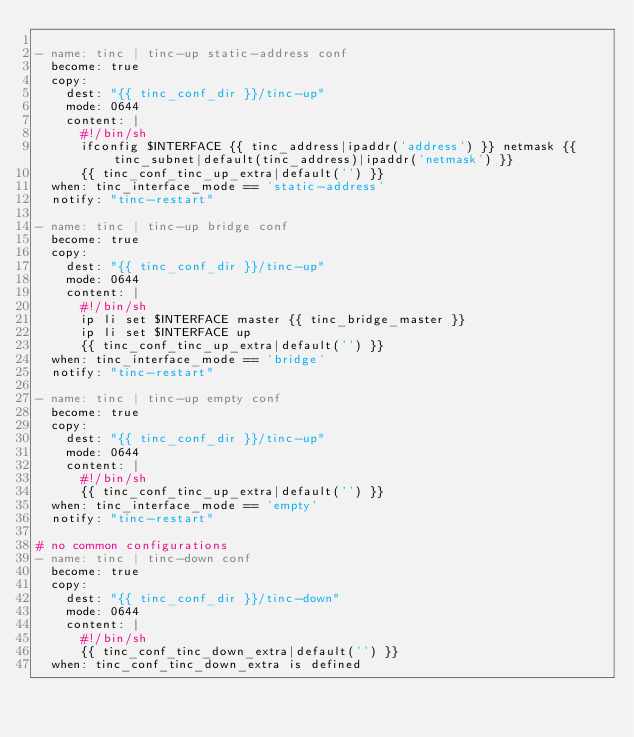Convert code to text. <code><loc_0><loc_0><loc_500><loc_500><_YAML_>
- name: tinc | tinc-up static-address conf
  become: true
  copy:
    dest: "{{ tinc_conf_dir }}/tinc-up"
    mode: 0644
    content: |
      #!/bin/sh
      ifconfig $INTERFACE {{ tinc_address|ipaddr('address') }} netmask {{ tinc_subnet|default(tinc_address)|ipaddr('netmask') }}
      {{ tinc_conf_tinc_up_extra|default('') }}
  when: tinc_interface_mode == 'static-address'
  notify: "tinc-restart"

- name: tinc | tinc-up bridge conf
  become: true
  copy:
    dest: "{{ tinc_conf_dir }}/tinc-up"
    mode: 0644
    content: |
      #!/bin/sh
      ip li set $INTERFACE master {{ tinc_bridge_master }}
      ip li set $INTERFACE up
      {{ tinc_conf_tinc_up_extra|default('') }}
  when: tinc_interface_mode == 'bridge'
  notify: "tinc-restart"

- name: tinc | tinc-up empty conf
  become: true
  copy:
    dest: "{{ tinc_conf_dir }}/tinc-up"
    mode: 0644
    content: |
      #!/bin/sh
      {{ tinc_conf_tinc_up_extra|default('') }}
  when: tinc_interface_mode == 'empty'
  notify: "tinc-restart"

# no common configurations
- name: tinc | tinc-down conf
  become: true
  copy:
    dest: "{{ tinc_conf_dir }}/tinc-down"
    mode: 0644
    content: |
      #!/bin/sh
      {{ tinc_conf_tinc_down_extra|default('') }}
  when: tinc_conf_tinc_down_extra is defined
</code> 